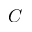Convert formula to latex. <formula><loc_0><loc_0><loc_500><loc_500>C</formula> 